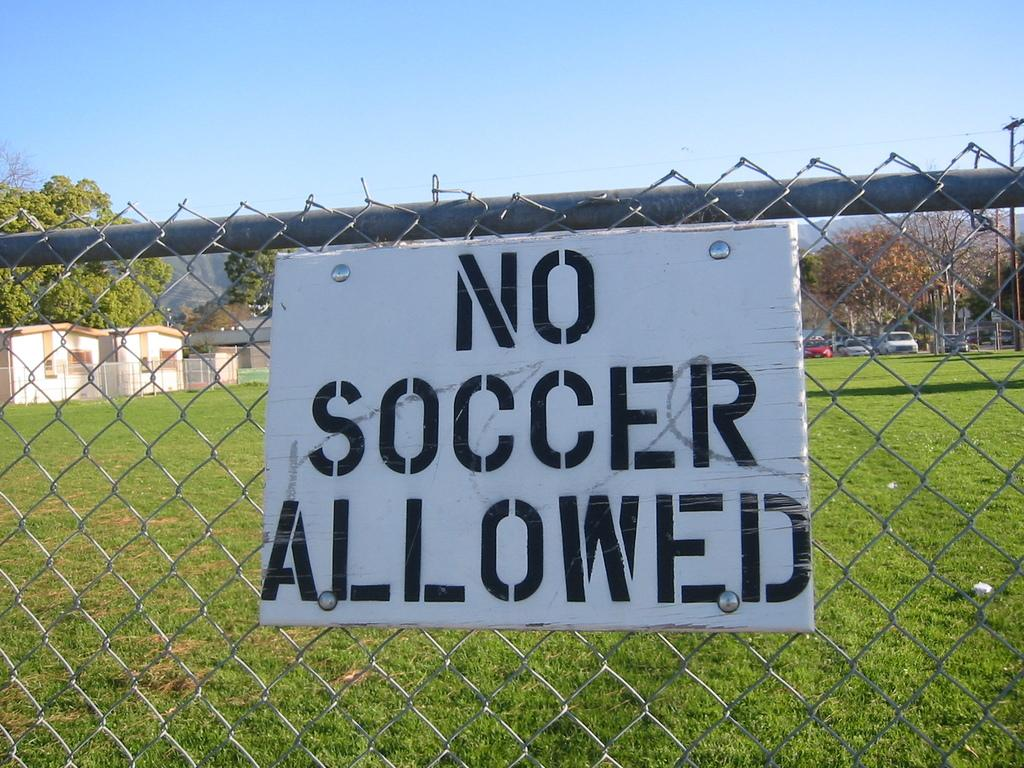What is attached to the fence in the image? There is a board attached to the fence in the image. What type of terrain is visible in the image? There is grass visible in the image. What can be seen in the distance in the image? Houses, vehicles, trees, and the sky are visible in the background of the image. What type of haircut is the train wearing in the image? There is no train present in the image, and therefore no haircut can be observed. 